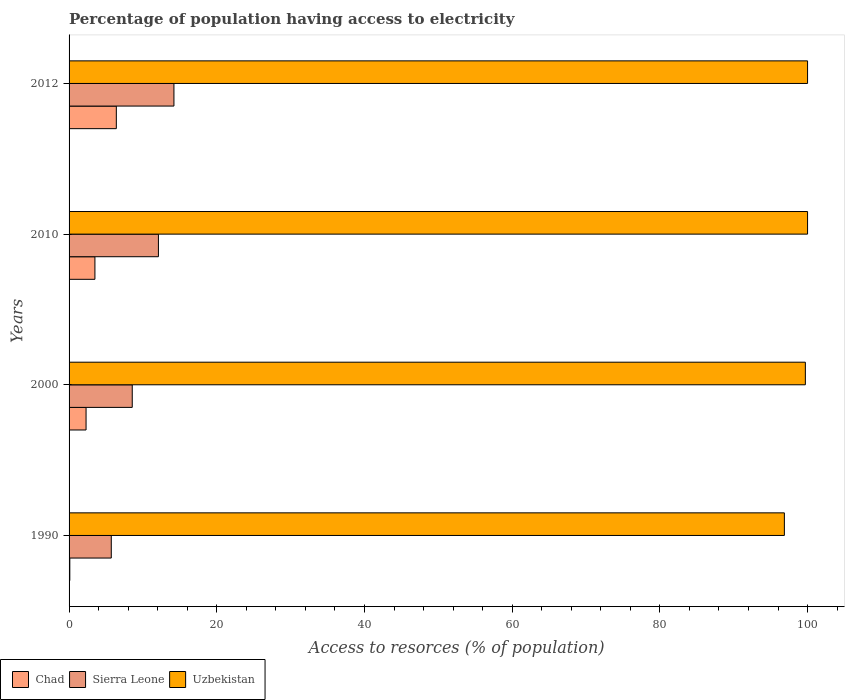How many groups of bars are there?
Provide a short and direct response. 4. How many bars are there on the 2nd tick from the top?
Your response must be concise. 3. What is the percentage of population having access to electricity in Sierra Leone in 2000?
Your response must be concise. 8.56. In which year was the percentage of population having access to electricity in Uzbekistan maximum?
Provide a short and direct response. 2010. In which year was the percentage of population having access to electricity in Chad minimum?
Your answer should be compact. 1990. What is the total percentage of population having access to electricity in Uzbekistan in the graph?
Your answer should be very brief. 396.56. What is the difference between the percentage of population having access to electricity in Sierra Leone in 2000 and that in 2012?
Keep it short and to the point. -5.64. What is the difference between the percentage of population having access to electricity in Uzbekistan in 2000 and the percentage of population having access to electricity in Sierra Leone in 2012?
Keep it short and to the point. 85.5. What is the average percentage of population having access to electricity in Chad per year?
Make the answer very short. 3.08. In the year 2010, what is the difference between the percentage of population having access to electricity in Uzbekistan and percentage of population having access to electricity in Sierra Leone?
Provide a short and direct response. 87.9. In how many years, is the percentage of population having access to electricity in Chad greater than 8 %?
Offer a very short reply. 0. What is the ratio of the percentage of population having access to electricity in Sierra Leone in 1990 to that in 2012?
Provide a succinct answer. 0.4. What is the difference between the highest and the second highest percentage of population having access to electricity in Chad?
Your answer should be very brief. 2.9. What is the difference between the highest and the lowest percentage of population having access to electricity in Sierra Leone?
Make the answer very short. 8.48. What does the 1st bar from the top in 2012 represents?
Provide a short and direct response. Uzbekistan. What does the 2nd bar from the bottom in 2010 represents?
Make the answer very short. Sierra Leone. How many bars are there?
Give a very brief answer. 12. How many years are there in the graph?
Keep it short and to the point. 4. What is the difference between two consecutive major ticks on the X-axis?
Your response must be concise. 20. Does the graph contain grids?
Ensure brevity in your answer.  No. Where does the legend appear in the graph?
Your answer should be compact. Bottom left. How are the legend labels stacked?
Provide a short and direct response. Horizontal. What is the title of the graph?
Ensure brevity in your answer.  Percentage of population having access to electricity. What is the label or title of the X-axis?
Your response must be concise. Access to resorces (% of population). What is the Access to resorces (% of population) in Sierra Leone in 1990?
Make the answer very short. 5.72. What is the Access to resorces (% of population) of Uzbekistan in 1990?
Make the answer very short. 96.86. What is the Access to resorces (% of population) of Chad in 2000?
Ensure brevity in your answer.  2.3. What is the Access to resorces (% of population) in Sierra Leone in 2000?
Your response must be concise. 8.56. What is the Access to resorces (% of population) of Uzbekistan in 2000?
Ensure brevity in your answer.  99.7. What is the Access to resorces (% of population) in Sierra Leone in 2012?
Offer a very short reply. 14.2. Across all years, what is the maximum Access to resorces (% of population) in Sierra Leone?
Offer a very short reply. 14.2. Across all years, what is the minimum Access to resorces (% of population) of Sierra Leone?
Ensure brevity in your answer.  5.72. Across all years, what is the minimum Access to resorces (% of population) in Uzbekistan?
Ensure brevity in your answer.  96.86. What is the total Access to resorces (% of population) in Chad in the graph?
Your response must be concise. 12.3. What is the total Access to resorces (% of population) in Sierra Leone in the graph?
Provide a succinct answer. 40.57. What is the total Access to resorces (% of population) in Uzbekistan in the graph?
Provide a succinct answer. 396.56. What is the difference between the Access to resorces (% of population) of Sierra Leone in 1990 and that in 2000?
Provide a short and direct response. -2.84. What is the difference between the Access to resorces (% of population) in Uzbekistan in 1990 and that in 2000?
Ensure brevity in your answer.  -2.84. What is the difference between the Access to resorces (% of population) in Sierra Leone in 1990 and that in 2010?
Ensure brevity in your answer.  -6.38. What is the difference between the Access to resorces (% of population) of Uzbekistan in 1990 and that in 2010?
Offer a terse response. -3.14. What is the difference between the Access to resorces (% of population) in Sierra Leone in 1990 and that in 2012?
Give a very brief answer. -8.48. What is the difference between the Access to resorces (% of population) in Uzbekistan in 1990 and that in 2012?
Offer a very short reply. -3.14. What is the difference between the Access to resorces (% of population) of Chad in 2000 and that in 2010?
Provide a succinct answer. -1.2. What is the difference between the Access to resorces (% of population) of Sierra Leone in 2000 and that in 2010?
Provide a short and direct response. -3.54. What is the difference between the Access to resorces (% of population) in Uzbekistan in 2000 and that in 2010?
Keep it short and to the point. -0.3. What is the difference between the Access to resorces (% of population) of Chad in 2000 and that in 2012?
Make the answer very short. -4.1. What is the difference between the Access to resorces (% of population) of Sierra Leone in 2000 and that in 2012?
Your answer should be compact. -5.64. What is the difference between the Access to resorces (% of population) of Chad in 2010 and that in 2012?
Your answer should be compact. -2.9. What is the difference between the Access to resorces (% of population) in Chad in 1990 and the Access to resorces (% of population) in Sierra Leone in 2000?
Offer a very short reply. -8.46. What is the difference between the Access to resorces (% of population) of Chad in 1990 and the Access to resorces (% of population) of Uzbekistan in 2000?
Provide a succinct answer. -99.6. What is the difference between the Access to resorces (% of population) in Sierra Leone in 1990 and the Access to resorces (% of population) in Uzbekistan in 2000?
Your answer should be very brief. -93.98. What is the difference between the Access to resorces (% of population) in Chad in 1990 and the Access to resorces (% of population) in Sierra Leone in 2010?
Your answer should be compact. -12. What is the difference between the Access to resorces (% of population) in Chad in 1990 and the Access to resorces (% of population) in Uzbekistan in 2010?
Keep it short and to the point. -99.9. What is the difference between the Access to resorces (% of population) in Sierra Leone in 1990 and the Access to resorces (% of population) in Uzbekistan in 2010?
Offer a very short reply. -94.28. What is the difference between the Access to resorces (% of population) of Chad in 1990 and the Access to resorces (% of population) of Sierra Leone in 2012?
Make the answer very short. -14.1. What is the difference between the Access to resorces (% of population) of Chad in 1990 and the Access to resorces (% of population) of Uzbekistan in 2012?
Offer a very short reply. -99.9. What is the difference between the Access to resorces (% of population) of Sierra Leone in 1990 and the Access to resorces (% of population) of Uzbekistan in 2012?
Provide a short and direct response. -94.28. What is the difference between the Access to resorces (% of population) in Chad in 2000 and the Access to resorces (% of population) in Sierra Leone in 2010?
Give a very brief answer. -9.8. What is the difference between the Access to resorces (% of population) of Chad in 2000 and the Access to resorces (% of population) of Uzbekistan in 2010?
Your answer should be compact. -97.7. What is the difference between the Access to resorces (% of population) of Sierra Leone in 2000 and the Access to resorces (% of population) of Uzbekistan in 2010?
Your answer should be compact. -91.44. What is the difference between the Access to resorces (% of population) in Chad in 2000 and the Access to resorces (% of population) in Sierra Leone in 2012?
Make the answer very short. -11.9. What is the difference between the Access to resorces (% of population) in Chad in 2000 and the Access to resorces (% of population) in Uzbekistan in 2012?
Make the answer very short. -97.7. What is the difference between the Access to resorces (% of population) in Sierra Leone in 2000 and the Access to resorces (% of population) in Uzbekistan in 2012?
Make the answer very short. -91.44. What is the difference between the Access to resorces (% of population) in Chad in 2010 and the Access to resorces (% of population) in Uzbekistan in 2012?
Your response must be concise. -96.5. What is the difference between the Access to resorces (% of population) in Sierra Leone in 2010 and the Access to resorces (% of population) in Uzbekistan in 2012?
Offer a very short reply. -87.9. What is the average Access to resorces (% of population) in Chad per year?
Your response must be concise. 3.08. What is the average Access to resorces (% of population) in Sierra Leone per year?
Give a very brief answer. 10.14. What is the average Access to resorces (% of population) in Uzbekistan per year?
Keep it short and to the point. 99.14. In the year 1990, what is the difference between the Access to resorces (% of population) of Chad and Access to resorces (% of population) of Sierra Leone?
Offer a very short reply. -5.62. In the year 1990, what is the difference between the Access to resorces (% of population) in Chad and Access to resorces (% of population) in Uzbekistan?
Keep it short and to the point. -96.76. In the year 1990, what is the difference between the Access to resorces (% of population) of Sierra Leone and Access to resorces (% of population) of Uzbekistan?
Make the answer very short. -91.14. In the year 2000, what is the difference between the Access to resorces (% of population) in Chad and Access to resorces (% of population) in Sierra Leone?
Make the answer very short. -6.26. In the year 2000, what is the difference between the Access to resorces (% of population) of Chad and Access to resorces (% of population) of Uzbekistan?
Your answer should be compact. -97.4. In the year 2000, what is the difference between the Access to resorces (% of population) of Sierra Leone and Access to resorces (% of population) of Uzbekistan?
Your response must be concise. -91.14. In the year 2010, what is the difference between the Access to resorces (% of population) in Chad and Access to resorces (% of population) in Sierra Leone?
Your answer should be compact. -8.6. In the year 2010, what is the difference between the Access to resorces (% of population) in Chad and Access to resorces (% of population) in Uzbekistan?
Provide a succinct answer. -96.5. In the year 2010, what is the difference between the Access to resorces (% of population) in Sierra Leone and Access to resorces (% of population) in Uzbekistan?
Ensure brevity in your answer.  -87.9. In the year 2012, what is the difference between the Access to resorces (% of population) in Chad and Access to resorces (% of population) in Uzbekistan?
Your answer should be very brief. -93.6. In the year 2012, what is the difference between the Access to resorces (% of population) in Sierra Leone and Access to resorces (% of population) in Uzbekistan?
Ensure brevity in your answer.  -85.8. What is the ratio of the Access to resorces (% of population) in Chad in 1990 to that in 2000?
Make the answer very short. 0.04. What is the ratio of the Access to resorces (% of population) of Sierra Leone in 1990 to that in 2000?
Ensure brevity in your answer.  0.67. What is the ratio of the Access to resorces (% of population) of Uzbekistan in 1990 to that in 2000?
Offer a very short reply. 0.97. What is the ratio of the Access to resorces (% of population) in Chad in 1990 to that in 2010?
Offer a very short reply. 0.03. What is the ratio of the Access to resorces (% of population) in Sierra Leone in 1990 to that in 2010?
Provide a short and direct response. 0.47. What is the ratio of the Access to resorces (% of population) in Uzbekistan in 1990 to that in 2010?
Ensure brevity in your answer.  0.97. What is the ratio of the Access to resorces (% of population) in Chad in 1990 to that in 2012?
Your response must be concise. 0.02. What is the ratio of the Access to resorces (% of population) of Sierra Leone in 1990 to that in 2012?
Make the answer very short. 0.4. What is the ratio of the Access to resorces (% of population) of Uzbekistan in 1990 to that in 2012?
Offer a terse response. 0.97. What is the ratio of the Access to resorces (% of population) in Chad in 2000 to that in 2010?
Give a very brief answer. 0.66. What is the ratio of the Access to resorces (% of population) in Sierra Leone in 2000 to that in 2010?
Offer a terse response. 0.71. What is the ratio of the Access to resorces (% of population) in Uzbekistan in 2000 to that in 2010?
Provide a short and direct response. 1. What is the ratio of the Access to resorces (% of population) of Chad in 2000 to that in 2012?
Ensure brevity in your answer.  0.36. What is the ratio of the Access to resorces (% of population) of Sierra Leone in 2000 to that in 2012?
Provide a short and direct response. 0.6. What is the ratio of the Access to resorces (% of population) of Uzbekistan in 2000 to that in 2012?
Provide a short and direct response. 1. What is the ratio of the Access to resorces (% of population) of Chad in 2010 to that in 2012?
Ensure brevity in your answer.  0.55. What is the ratio of the Access to resorces (% of population) of Sierra Leone in 2010 to that in 2012?
Make the answer very short. 0.85. What is the difference between the highest and the second highest Access to resorces (% of population) in Chad?
Make the answer very short. 2.9. What is the difference between the highest and the lowest Access to resorces (% of population) of Chad?
Your answer should be compact. 6.3. What is the difference between the highest and the lowest Access to resorces (% of population) in Sierra Leone?
Make the answer very short. 8.48. What is the difference between the highest and the lowest Access to resorces (% of population) in Uzbekistan?
Provide a short and direct response. 3.14. 